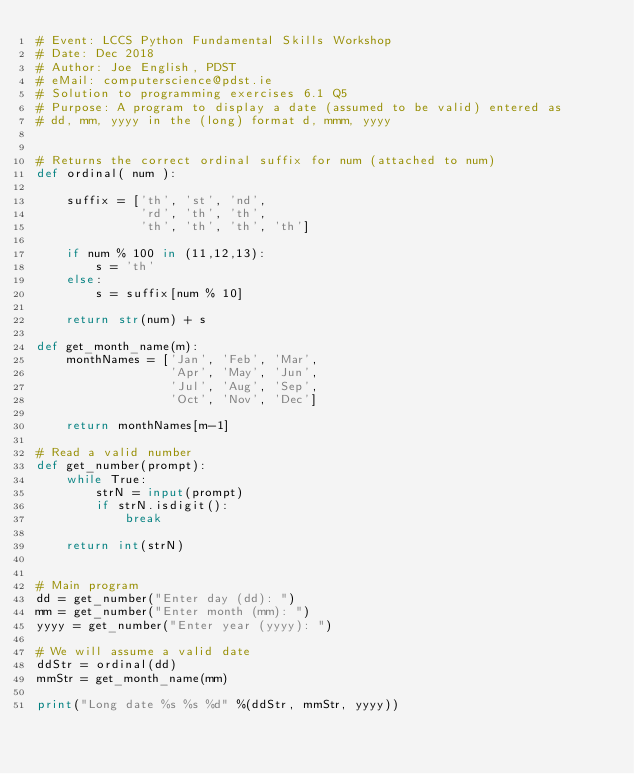Convert code to text. <code><loc_0><loc_0><loc_500><loc_500><_Python_># Event: LCCS Python Fundamental Skills Workshop
# Date: Dec 2018
# Author: Joe English, PDST
# eMail: computerscience@pdst.ie
# Solution to programming exercises 6.1 Q5
# Purpose: A program to display a date (assumed to be valid) entered as
# dd, mm, yyyy in the (long) format d, mmm, yyyy


# Returns the correct ordinal suffix for num (attached to num)
def ordinal( num ):

    suffix = ['th', 'st', 'nd',
              'rd', 'th', 'th',
              'th', 'th', 'th', 'th']

    if num % 100 in (11,12,13):
        s = 'th'
    else:
        s = suffix[num % 10]

    return str(num) + s

def get_month_name(m):
    monthNames = ['Jan', 'Feb', 'Mar',
                  'Apr', 'May', 'Jun',
                  'Jul', 'Aug', 'Sep',
                  'Oct', 'Nov', 'Dec']
   
    return monthNames[m-1]

# Read a valid number
def get_number(prompt):
    while True:
        strN = input(prompt)
        if strN.isdigit():
            break
        
    return int(strN)    


# Main program
dd = get_number("Enter day (dd): ")
mm = get_number("Enter month (mm): ")
yyyy = get_number("Enter year (yyyy): ")

# We will assume a valid date
ddStr = ordinal(dd)
mmStr = get_month_name(mm)

print("Long date %s %s %d" %(ddStr, mmStr, yyyy))</code> 